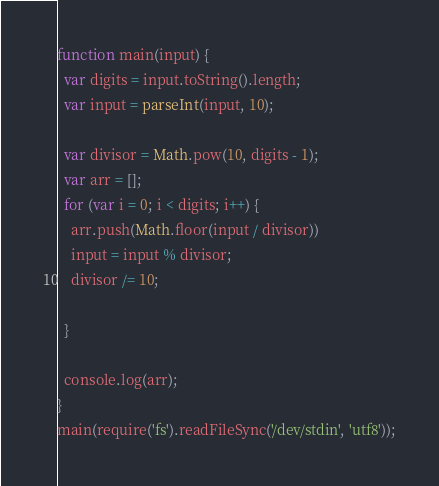Convert code to text. <code><loc_0><loc_0><loc_500><loc_500><_JavaScript_>function main(input) {
  var digits = input.toString().length;
  var input = parseInt(input, 10);

  var divisor = Math.pow(10, digits - 1);
  var arr = [];
  for (var i = 0; i < digits; i++) {
  	arr.push(Math.floor(input / divisor))
  	input = input % divisor;
  	divisor /= 10;

  }

  console.log(arr);
}
main(require('fs').readFileSync('/dev/stdin', 'utf8'));</code> 